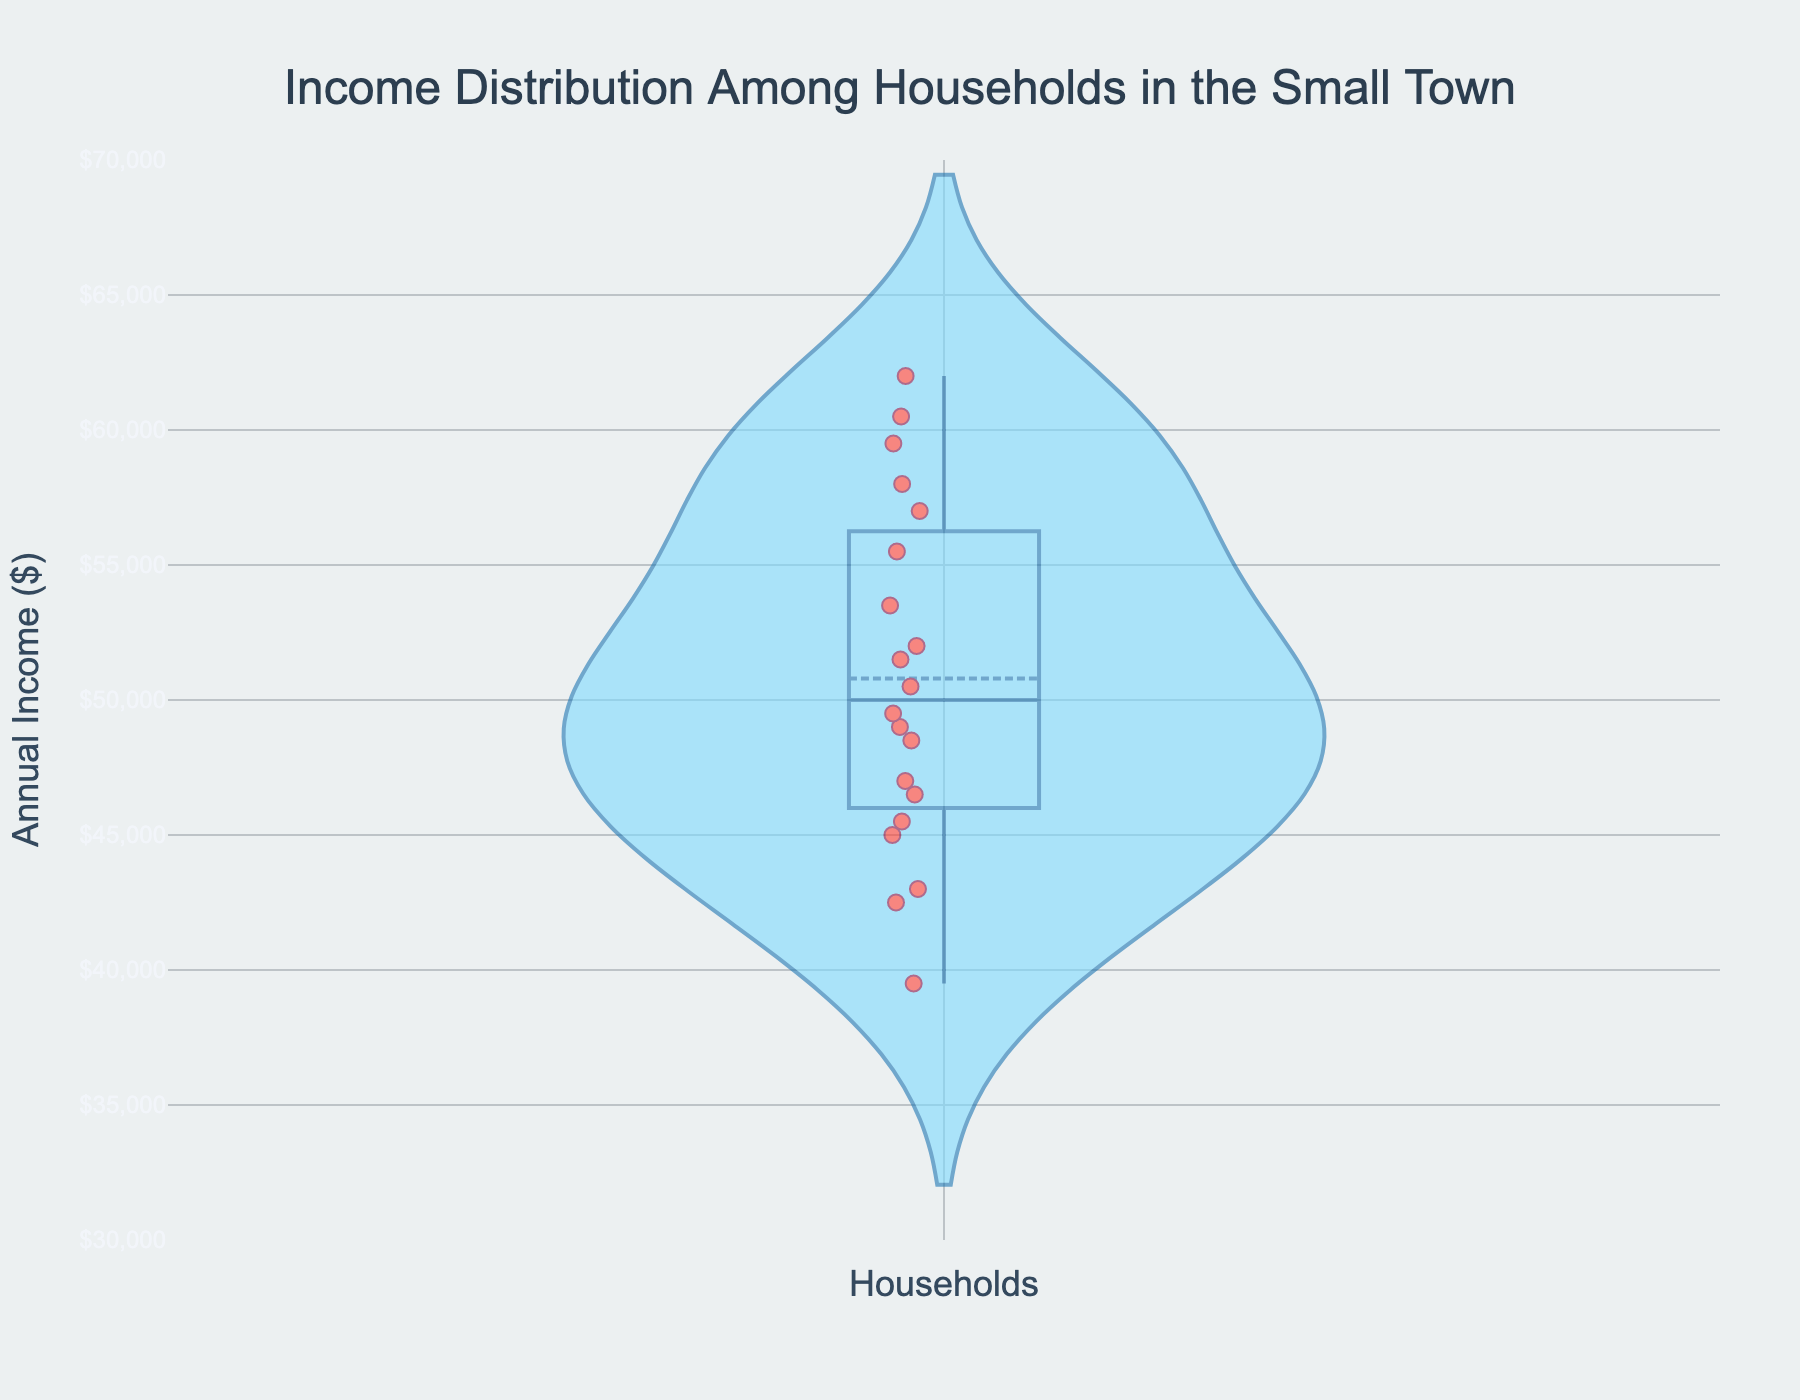What is the title of the figure? The title is usually prominently displayed at the top of the figure. In this plot, it is "Income Distribution Among Households in the Small Town".
Answer: Income Distribution Among Households in the Small Town What is the range of the y-axis? The y-axis shows the annual income in dollars. Based on the axis labels, it ranges from $30,000 to $70,000.
Answer: $30,000 to $70,000 How many households are represented in the figure? By looking at the number of points plotted in the violin chart and counting them, we can see that there are 20 households represented.
Answer: 20 Which household has the lowest income and what is it? The lowest income is shown at the bottom of the violin chart. By inspecting the chart, we can identify that the Brown Family has the lowest income, which is $39,500.
Answer: Brown Family, $39,500 Which household has the highest income and what is it? The highest income is shown at the top of the violin chart. By inspecting the chart, we can identify that the Davis Family has the highest income, which is $62,000.
Answer: Davis Family, $62,000 What is the median household income? The median is typically the middle value when the data points are arranged in order. In a violin plot, it is shown as a horizontal line within the chart. The median income in this figure is at $49,750.
Answer: $49,750 What is the approximate interquartile range (IQR) of the incomes? The IQR can be approximated by the spread of the box within the violin plot. The first quartile (Q1) is around $43,000 and the third quartile (Q3) is around $59,500. The IQR is Q3 - Q1 = $59,500 - $43,000 = $16,500.
Answer: $16,500 Which family falls at the mean income and what is it? The mean income is often shown as a line or point within a violin plot. By inspecting the chart, the mean income is around $49,100 which is close to values for Martinez Family.
Answer: Martinez Family, $49,100 How does the income of the Lopez Family compare to the median? The Lopez Family’s income is $51,500, which is slightly above the median income of $49,750 shown in the chart.
Answer: Slightly above What can we infer about the distribution of incomes from the shape of the violin plot? The shape of the violin plot indicates the density of income data points. It appears relatively symmetrical with more density in the middle range and some spread towards the tails, indicating a somewhat normal distribution but with slight skewness due to some higher income outliers.
Answer: Somewhat normal distribution with slight skewness towards higher incomes 